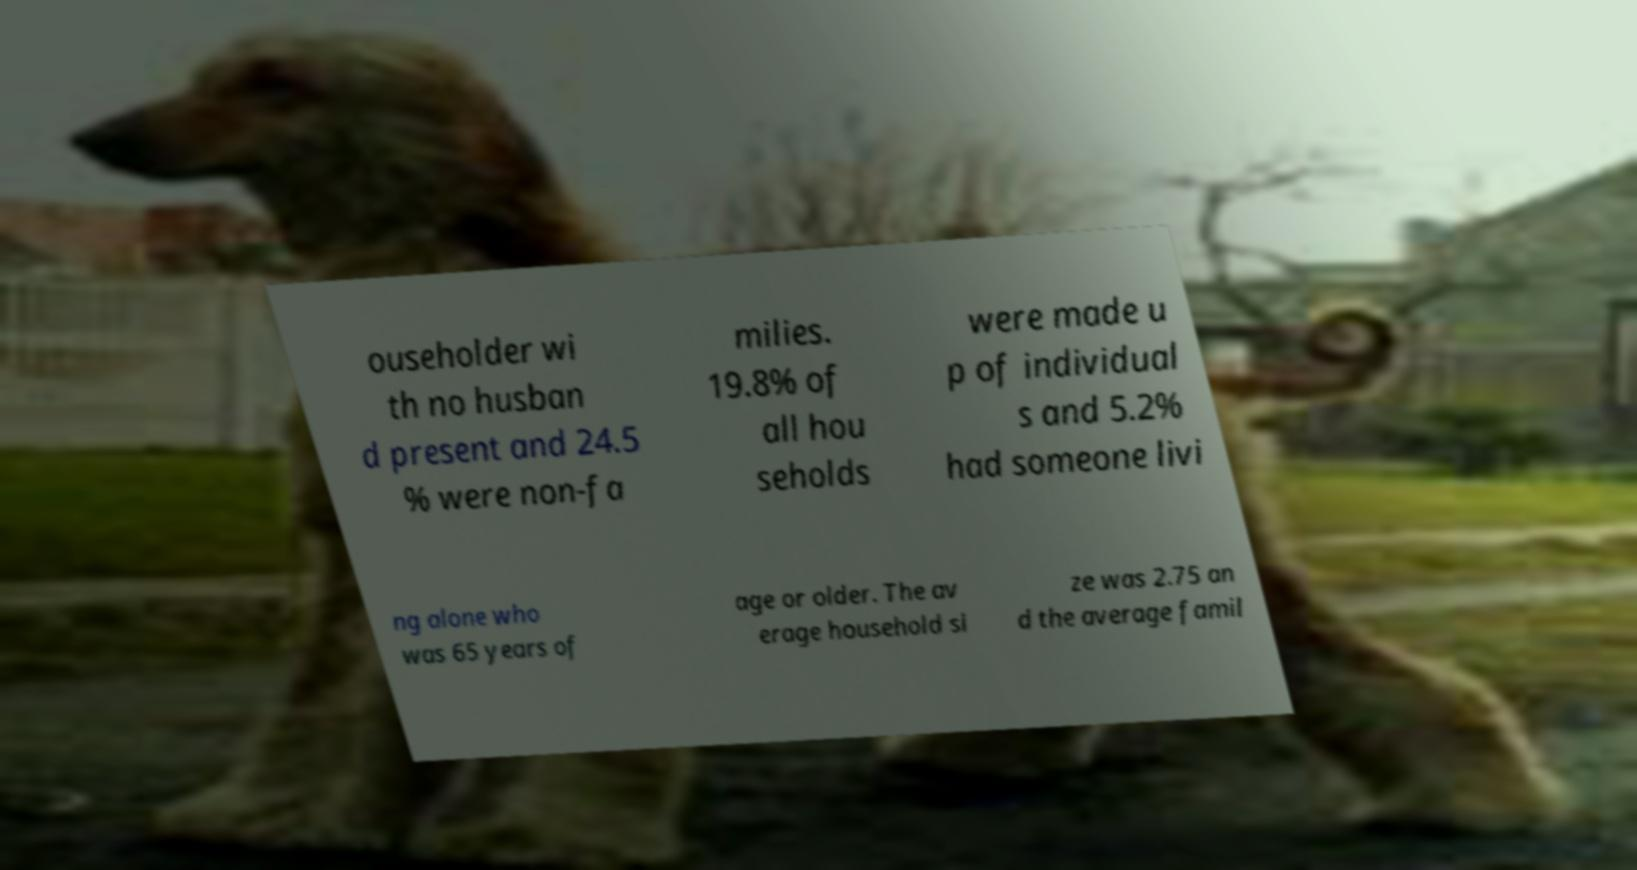I need the written content from this picture converted into text. Can you do that? ouseholder wi th no husban d present and 24.5 % were non-fa milies. 19.8% of all hou seholds were made u p of individual s and 5.2% had someone livi ng alone who was 65 years of age or older. The av erage household si ze was 2.75 an d the average famil 